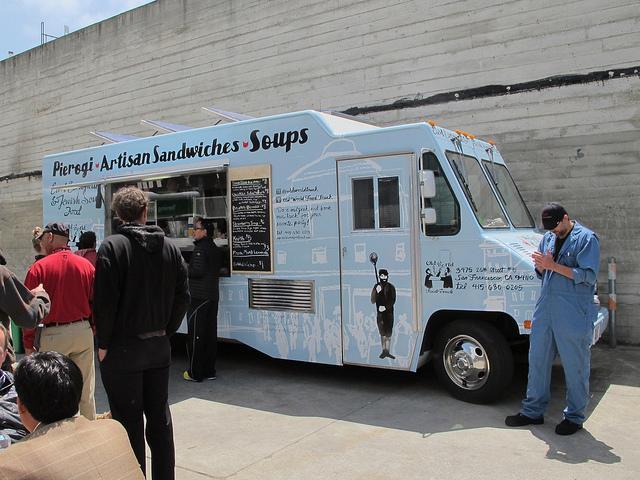How many people are there?
Give a very brief answer. 6. 